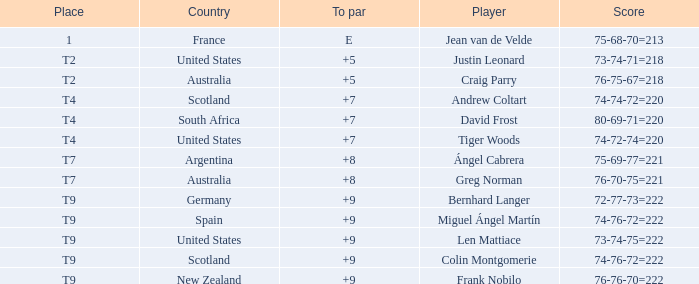What is the To Par score for the player from South Africa? 7.0. 